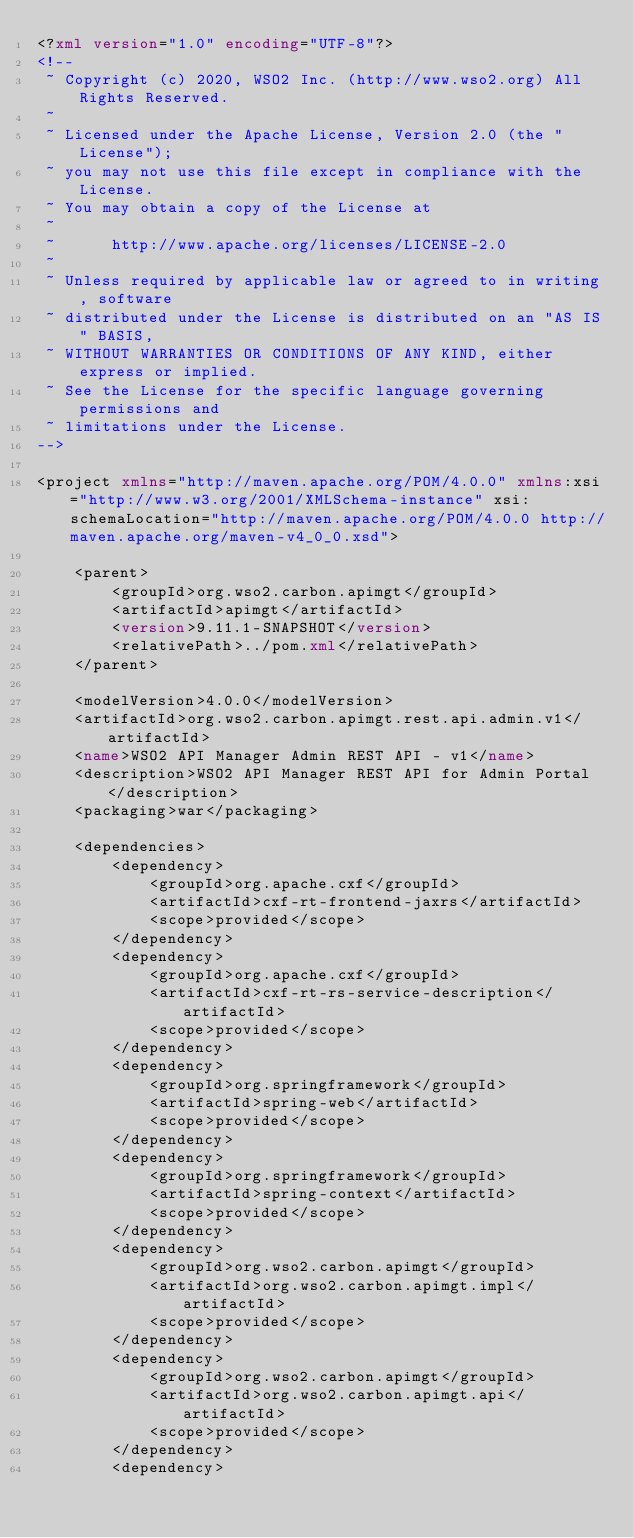Convert code to text. <code><loc_0><loc_0><loc_500><loc_500><_XML_><?xml version="1.0" encoding="UTF-8"?>
<!--
 ~ Copyright (c) 2020, WSO2 Inc. (http://www.wso2.org) All Rights Reserved.
 ~
 ~ Licensed under the Apache License, Version 2.0 (the "License");
 ~ you may not use this file except in compliance with the License.
 ~ You may obtain a copy of the License at
 ~
 ~      http://www.apache.org/licenses/LICENSE-2.0
 ~
 ~ Unless required by applicable law or agreed to in writing, software
 ~ distributed under the License is distributed on an "AS IS" BASIS,
 ~ WITHOUT WARRANTIES OR CONDITIONS OF ANY KIND, either express or implied.
 ~ See the License for the specific language governing permissions and
 ~ limitations under the License.
-->

<project xmlns="http://maven.apache.org/POM/4.0.0" xmlns:xsi="http://www.w3.org/2001/XMLSchema-instance" xsi:schemaLocation="http://maven.apache.org/POM/4.0.0 http://maven.apache.org/maven-v4_0_0.xsd">

    <parent>
        <groupId>org.wso2.carbon.apimgt</groupId>
        <artifactId>apimgt</artifactId>
        <version>9.11.1-SNAPSHOT</version>
        <relativePath>../pom.xml</relativePath>
    </parent>

    <modelVersion>4.0.0</modelVersion>
    <artifactId>org.wso2.carbon.apimgt.rest.api.admin.v1</artifactId>
    <name>WSO2 API Manager Admin REST API - v1</name>
    <description>WSO2 API Manager REST API for Admin Portal</description>
    <packaging>war</packaging>

    <dependencies>
        <dependency>
            <groupId>org.apache.cxf</groupId>
            <artifactId>cxf-rt-frontend-jaxrs</artifactId>
            <scope>provided</scope>
        </dependency>
        <dependency>
            <groupId>org.apache.cxf</groupId>
            <artifactId>cxf-rt-rs-service-description</artifactId>
            <scope>provided</scope>
        </dependency>
        <dependency>
            <groupId>org.springframework</groupId>
            <artifactId>spring-web</artifactId>
            <scope>provided</scope>
        </dependency>
        <dependency>
            <groupId>org.springframework</groupId>
            <artifactId>spring-context</artifactId>
            <scope>provided</scope>
        </dependency>
        <dependency>
            <groupId>org.wso2.carbon.apimgt</groupId>
            <artifactId>org.wso2.carbon.apimgt.impl</artifactId>
            <scope>provided</scope>
        </dependency>
        <dependency>
            <groupId>org.wso2.carbon.apimgt</groupId>
            <artifactId>org.wso2.carbon.apimgt.api</artifactId>
            <scope>provided</scope>
        </dependency>
        <dependency></code> 